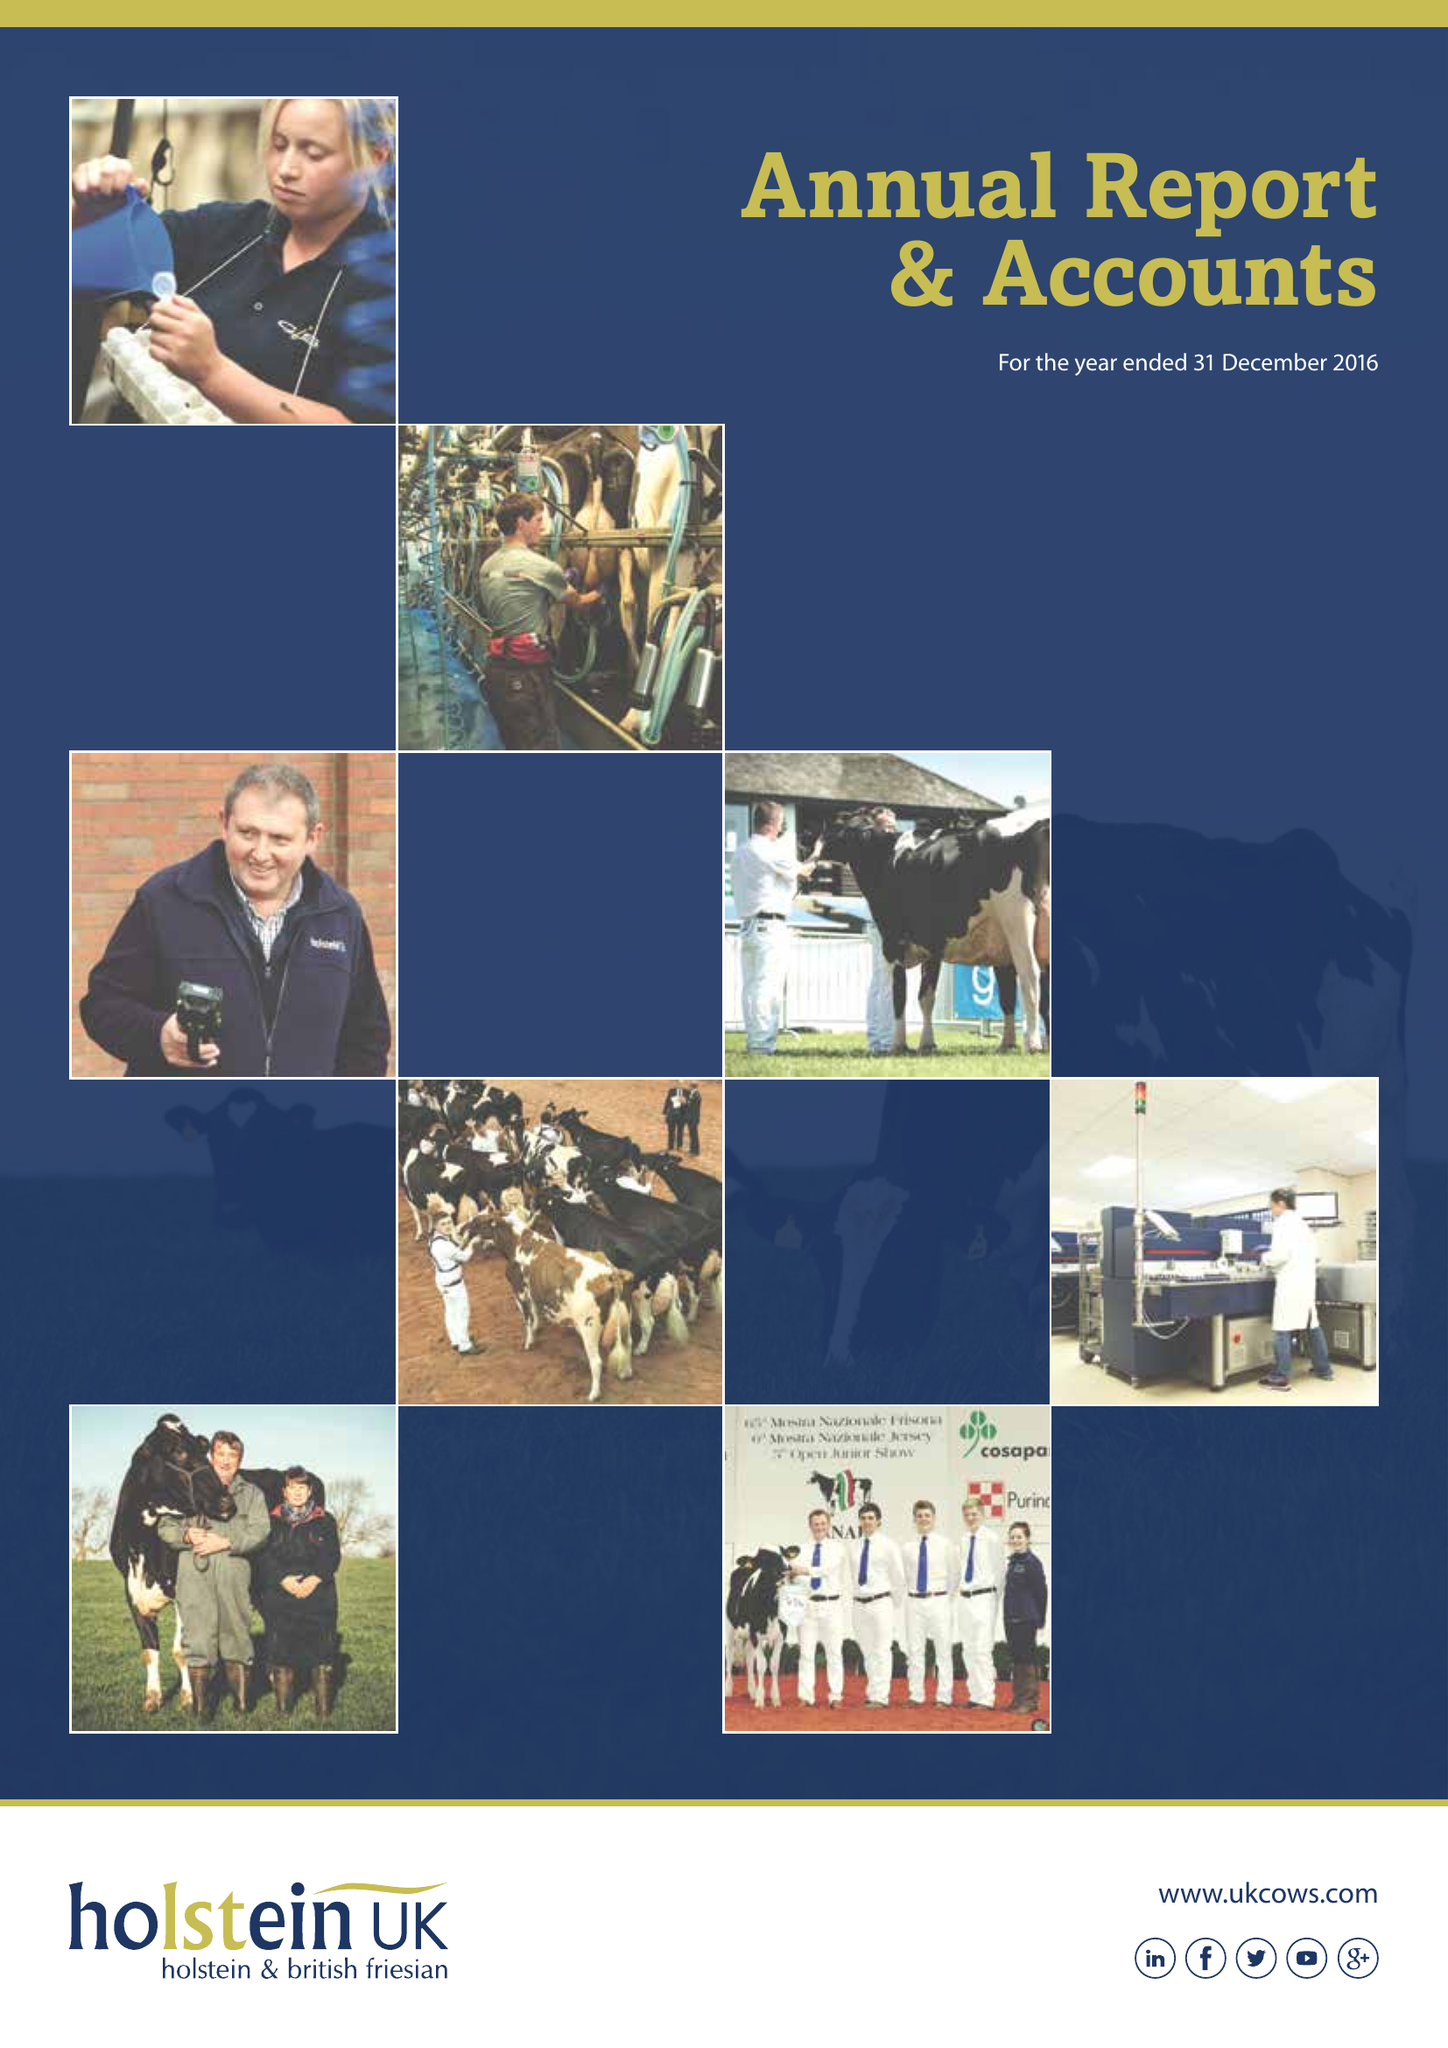What is the value for the charity_name?
Answer the question using a single word or phrase. Holstein Uk 